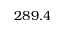Convert formula to latex. <formula><loc_0><loc_0><loc_500><loc_500>2 8 9 . 4</formula> 